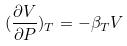Convert formula to latex. <formula><loc_0><loc_0><loc_500><loc_500>( \frac { \partial V } { \partial P } ) _ { T } = - \beta _ { T } V</formula> 